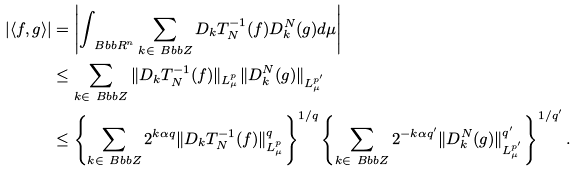<formula> <loc_0><loc_0><loc_500><loc_500>| \langle f , g \rangle | & = \left | \int _ { \ B b b R ^ { n } } \sum _ { k \in \ B b b Z } D _ { k } T ^ { - 1 } _ { N } ( f ) D ^ { N } _ { k } ( g ) d \mu \right | \\ & \leq \sum _ { k \in \ B b b Z } \| D _ { k } T ^ { - 1 } _ { N } ( f ) \| _ { L ^ { p } _ { \mu } } \| D ^ { N } _ { k } ( g ) \| _ { L ^ { p ^ { \prime } } _ { \mu } } \\ & \leq \left \{ \sum _ { k \in \ B b b Z } 2 ^ { k \alpha q } \| D _ { k } T ^ { - 1 } _ { N } ( f ) \| _ { L ^ { p } _ { \mu } } ^ { q } \right \} ^ { 1 / q } \left \{ \sum _ { k \in \ B b b Z } 2 ^ { - k \alpha q ^ { \prime } } \| D ^ { N } _ { k } ( g ) \| _ { L ^ { p ^ { \prime } } _ { \mu } } ^ { q ^ { \prime } } \right \} ^ { 1 / q ^ { \prime } } .</formula> 